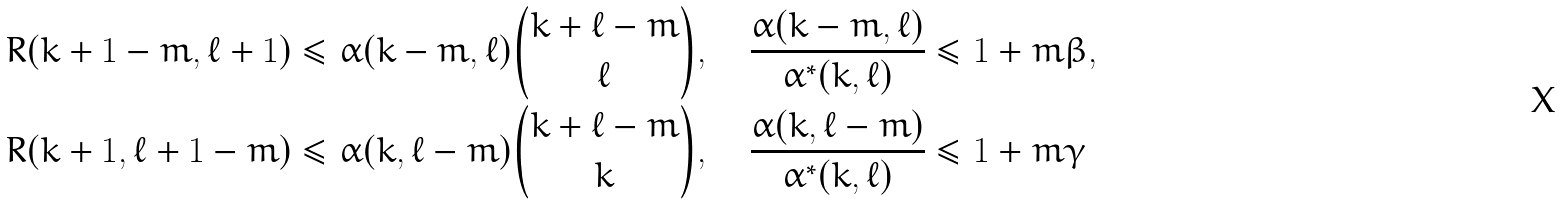<formula> <loc_0><loc_0><loc_500><loc_500>& R ( k + 1 - m , \ell + 1 ) \leq \alpha ( k - m , \ell ) \binom { k + \ell - m } { \ell } , \quad \frac { \alpha ( k - m , \ell ) } { \alpha ^ { \ast } ( k , \ell ) } \leq 1 + m \beta , \\ & R ( k + 1 , \ell + 1 - m ) \leq \alpha ( k , \ell - m ) \binom { k + \ell - m } { k } , \quad \frac { \alpha ( k , \ell - m ) } { \alpha ^ { \ast } ( k , \ell ) } \leq 1 + m \gamma</formula> 